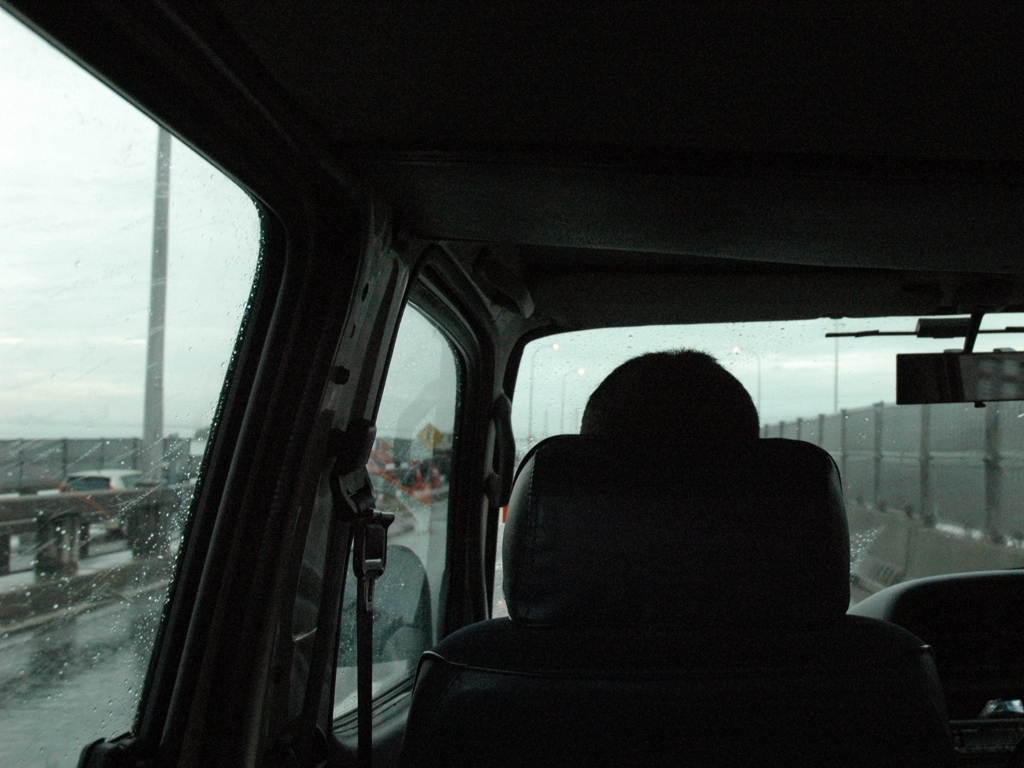What emotions does this image evoke? The image captures a contemplative mood, with the muted colors and rain creating a sense of introspection or melancholy. The solitary figure and the overcast sky suggest a journey or a moment of solitude. 